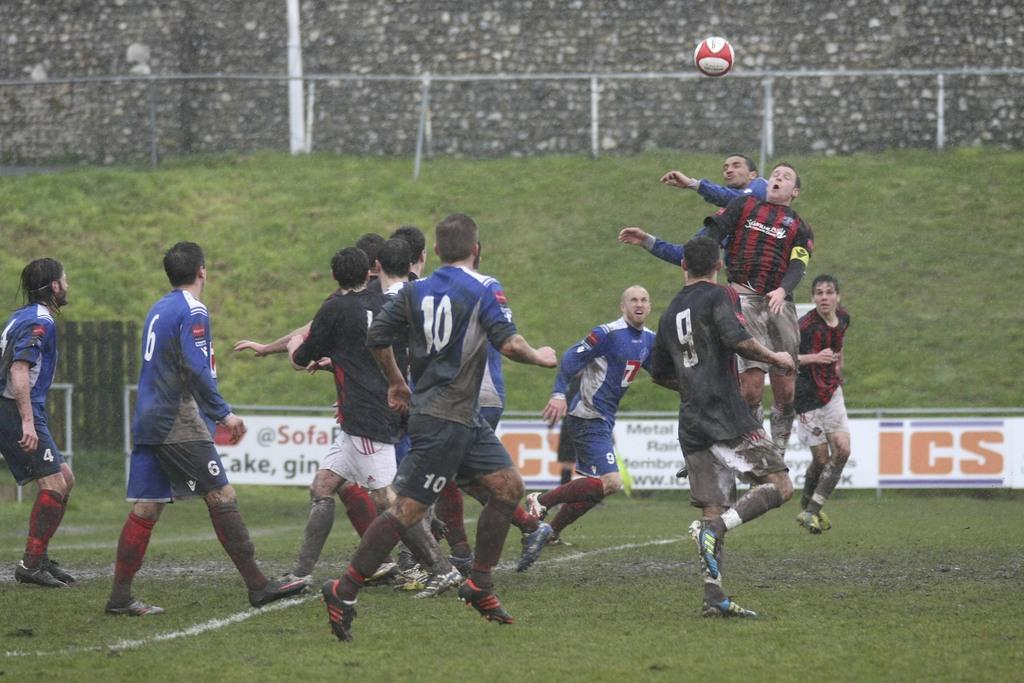<image>
Share a concise interpretation of the image provided. A sign has the logo ICS on it on a soccer field. 